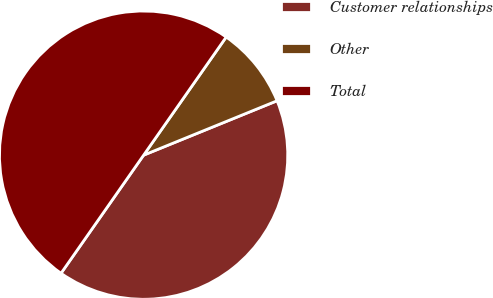Convert chart to OTSL. <chart><loc_0><loc_0><loc_500><loc_500><pie_chart><fcel>Customer relationships<fcel>Other<fcel>Total<nl><fcel>40.87%<fcel>9.13%<fcel>50.0%<nl></chart> 